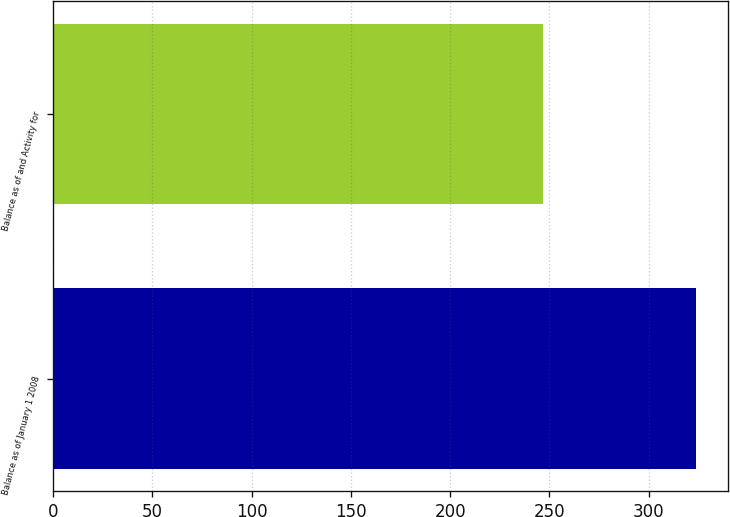Convert chart to OTSL. <chart><loc_0><loc_0><loc_500><loc_500><bar_chart><fcel>Balance as of January 1 2008<fcel>Balance as of and Activity for<nl><fcel>324<fcel>246.6<nl></chart> 